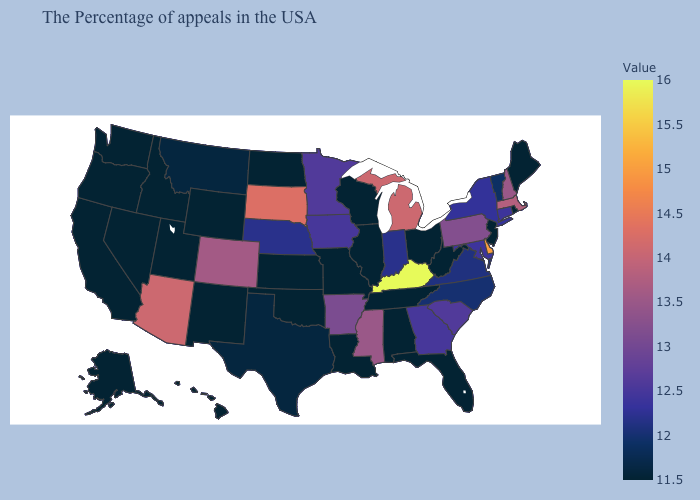Does Mississippi have a lower value than Kentucky?
Be succinct. Yes. Which states hav the highest value in the West?
Quick response, please. Arizona. Does the map have missing data?
Concise answer only. No. Does Montana have the lowest value in the West?
Answer briefly. No. Among the states that border California , which have the lowest value?
Quick response, please. Nevada, Oregon. Among the states that border Michigan , does Indiana have the lowest value?
Quick response, please. No. Among the states that border Vermont , does New York have the lowest value?
Concise answer only. Yes. 